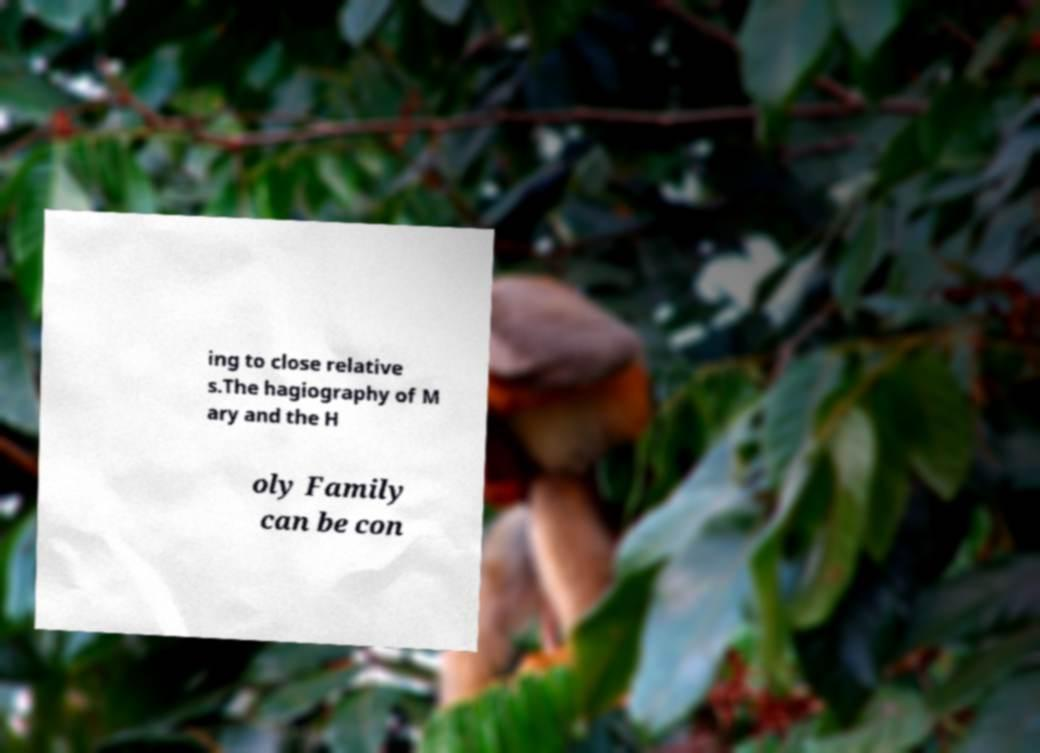Could you assist in decoding the text presented in this image and type it out clearly? ing to close relative s.The hagiography of M ary and the H oly Family can be con 